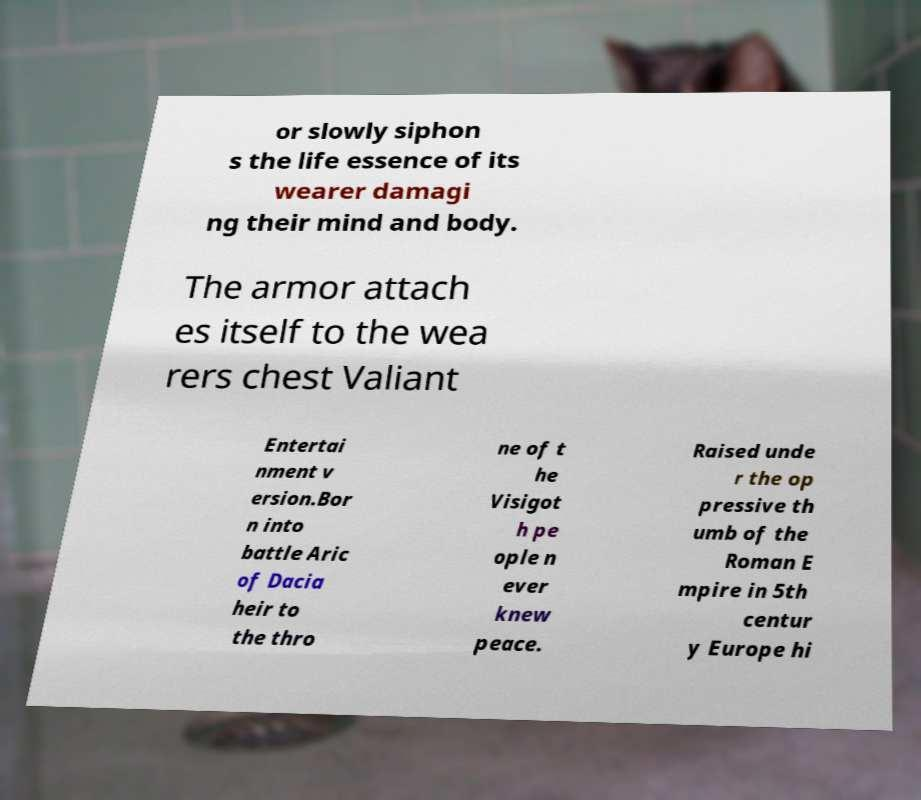Could you extract and type out the text from this image? or slowly siphon s the life essence of its wearer damagi ng their mind and body. The armor attach es itself to the wea rers chest Valiant Entertai nment v ersion.Bor n into battle Aric of Dacia heir to the thro ne of t he Visigot h pe ople n ever knew peace. Raised unde r the op pressive th umb of the Roman E mpire in 5th centur y Europe hi 